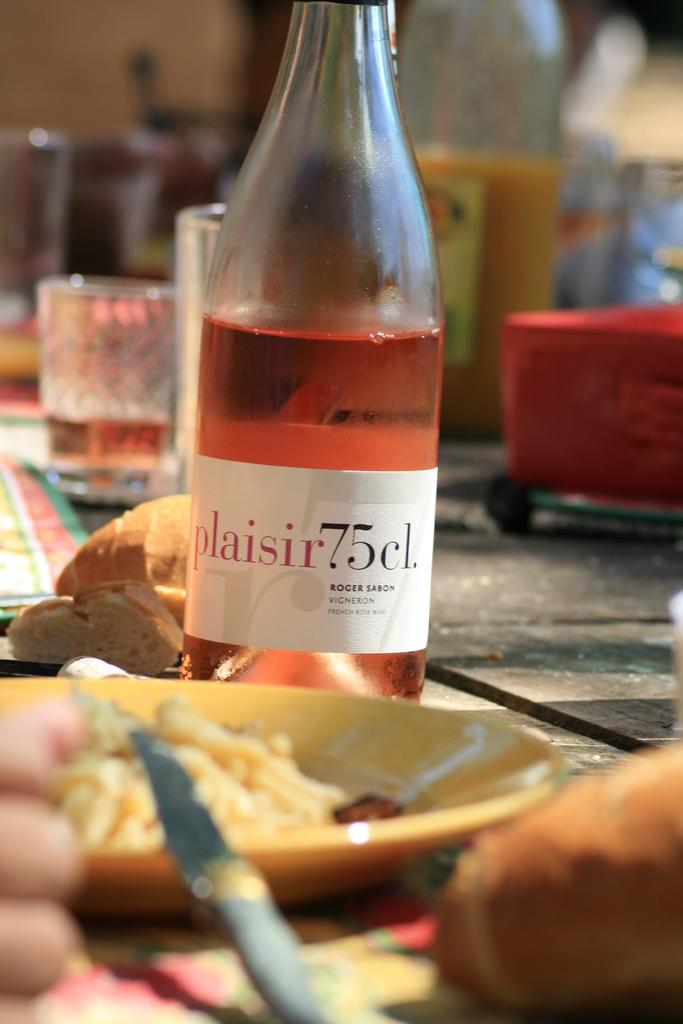<image>
Present a compact description of the photo's key features. the number 75 that is on a bottle 